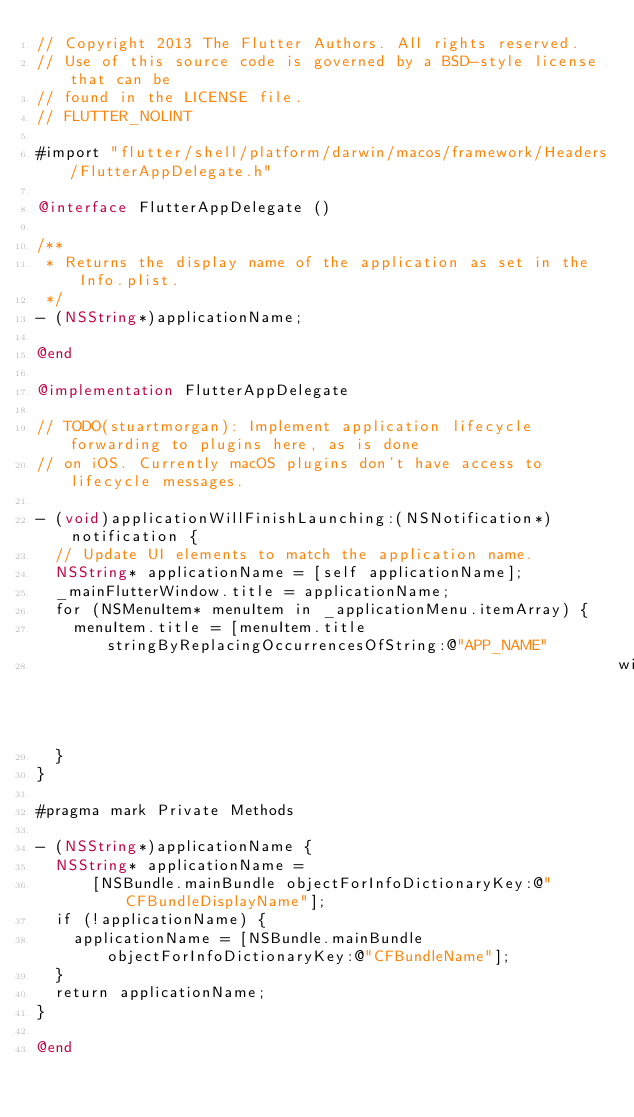<code> <loc_0><loc_0><loc_500><loc_500><_ObjectiveC_>// Copyright 2013 The Flutter Authors. All rights reserved.
// Use of this source code is governed by a BSD-style license that can be
// found in the LICENSE file.
// FLUTTER_NOLINT

#import "flutter/shell/platform/darwin/macos/framework/Headers/FlutterAppDelegate.h"

@interface FlutterAppDelegate ()

/**
 * Returns the display name of the application as set in the Info.plist.
 */
- (NSString*)applicationName;

@end

@implementation FlutterAppDelegate

// TODO(stuartmorgan): Implement application lifecycle forwarding to plugins here, as is done
// on iOS. Currently macOS plugins don't have access to lifecycle messages.

- (void)applicationWillFinishLaunching:(NSNotification*)notification {
  // Update UI elements to match the application name.
  NSString* applicationName = [self applicationName];
  _mainFlutterWindow.title = applicationName;
  for (NSMenuItem* menuItem in _applicationMenu.itemArray) {
    menuItem.title = [menuItem.title stringByReplacingOccurrencesOfString:@"APP_NAME"
                                                               withString:applicationName];
  }
}

#pragma mark Private Methods

- (NSString*)applicationName {
  NSString* applicationName =
      [NSBundle.mainBundle objectForInfoDictionaryKey:@"CFBundleDisplayName"];
  if (!applicationName) {
    applicationName = [NSBundle.mainBundle objectForInfoDictionaryKey:@"CFBundleName"];
  }
  return applicationName;
}

@end
</code> 